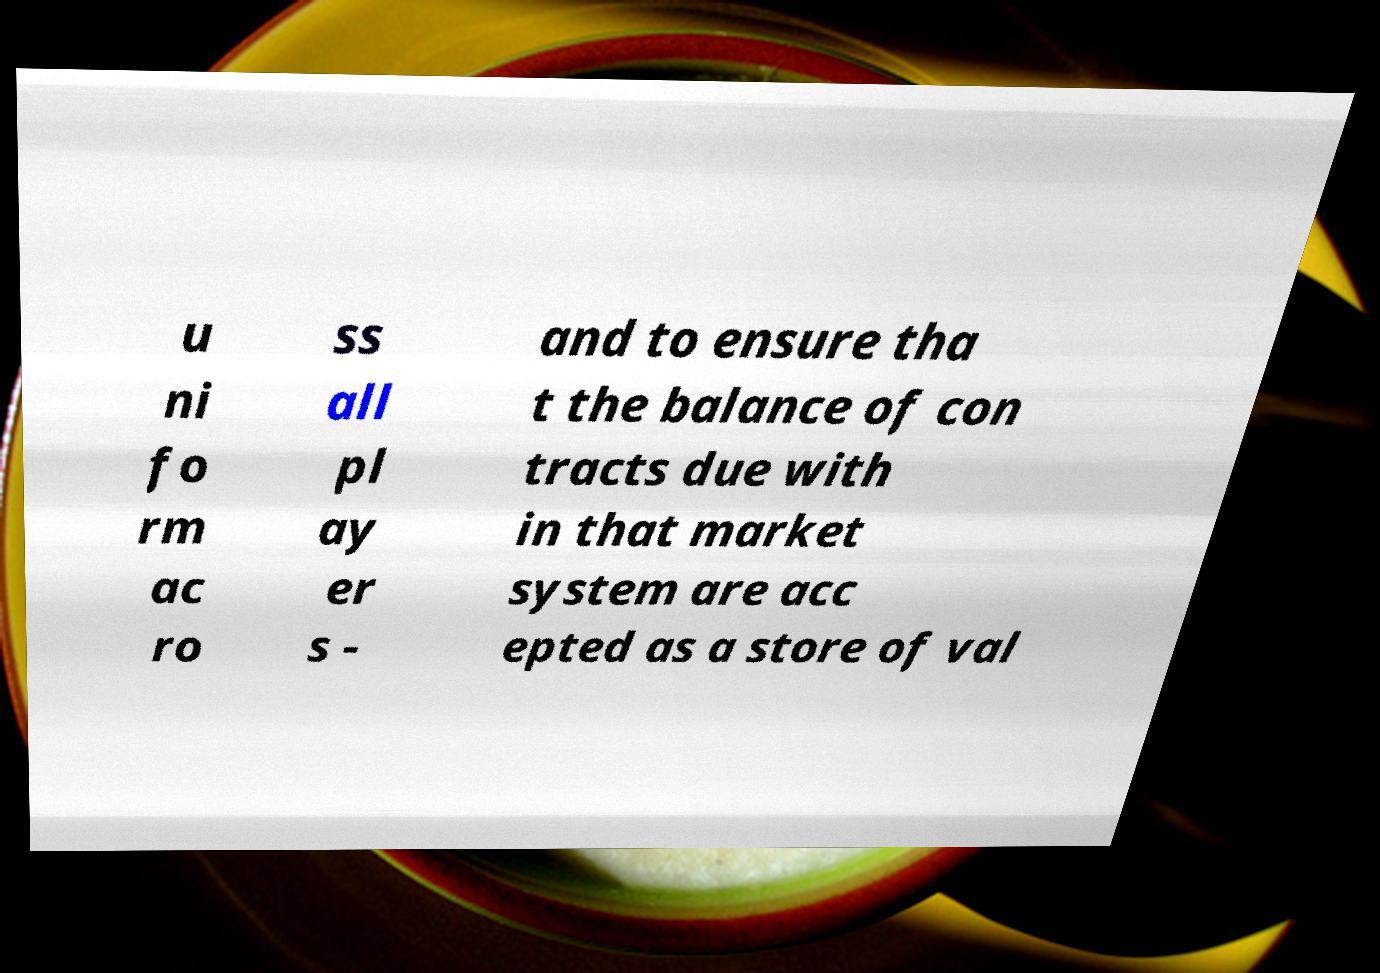For documentation purposes, I need the text within this image transcribed. Could you provide that? u ni fo rm ac ro ss all pl ay er s - and to ensure tha t the balance of con tracts due with in that market system are acc epted as a store of val 